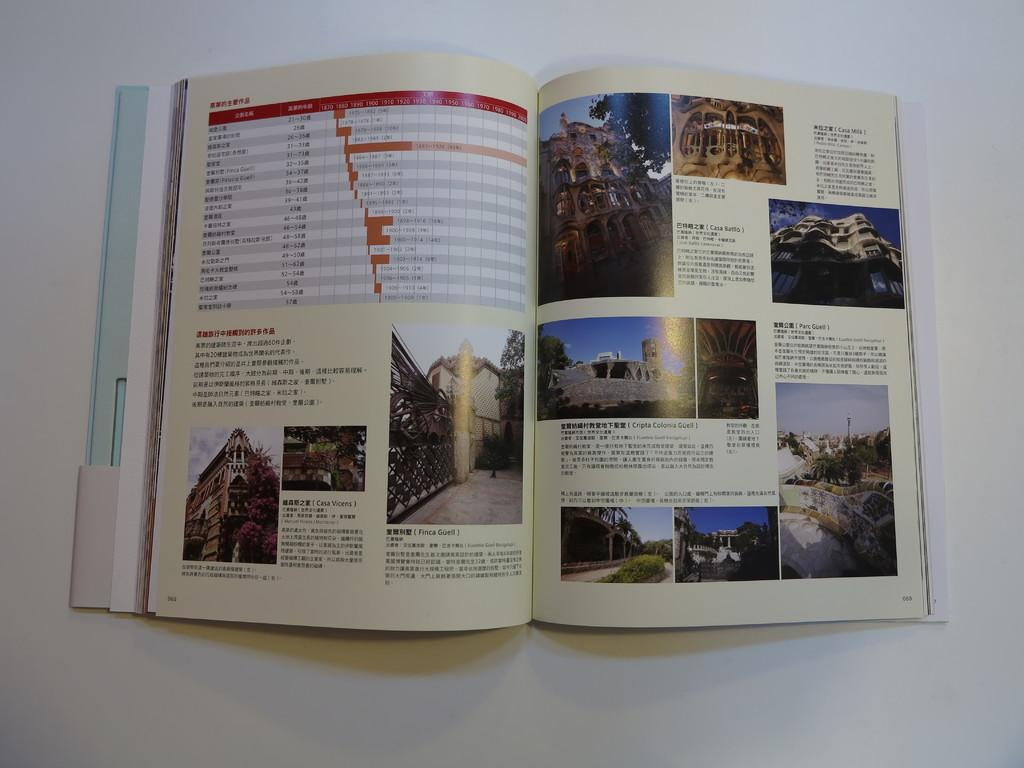What object can be seen in the image that is related to reading or learning? There is a book in the image. What is the state of the book in the image? The book is opened. Where is the book located in the image? The book is placed on a surface. What type of twig is being used to stir the book in the image? There is no twig present in the image, and the book is not being stirred. 